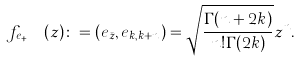Convert formula to latex. <formula><loc_0><loc_0><loc_500><loc_500>f _ { e _ { k , k + n } } ( z ) \colon = ( e _ { \bar { z } } , e _ { k , k + n } ) = \sqrt { \frac { \Gamma ( n + 2 k ) } { n ! \Gamma ( 2 k ) } } z ^ { n } .</formula> 